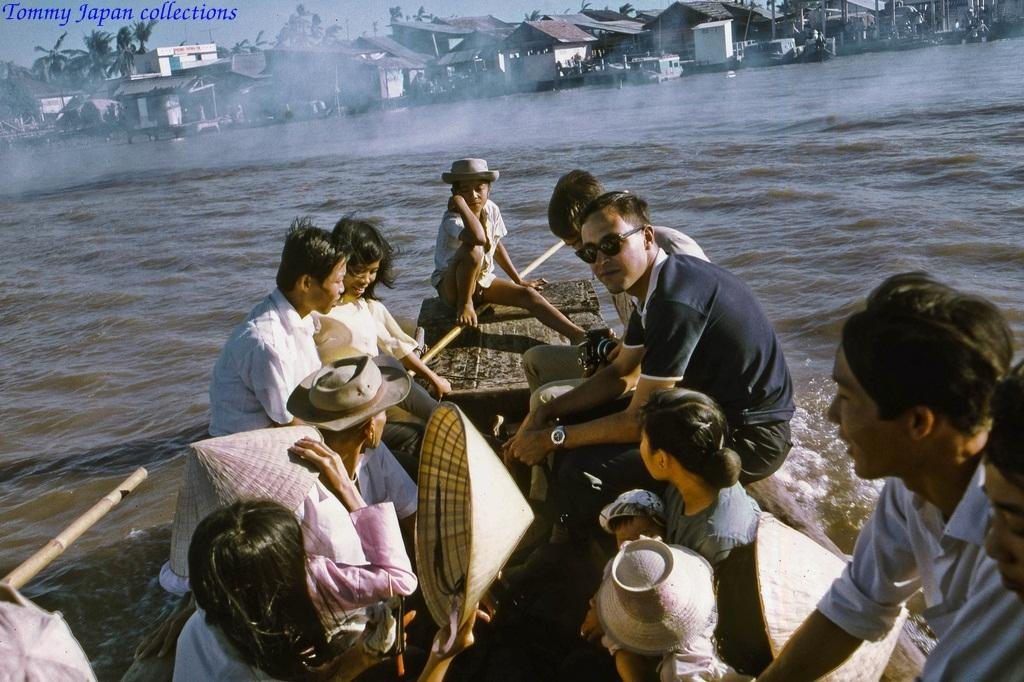What activity are the people in the image engaged in? There is a group of people boating in the water. What structures can be seen in the image? There are houses visible in the image. What type of vegetation is present in the image? There are trees visible in the image. What else can be seen in the image besides the people and structures? There is text visible in the image. What is visible in the background of the image? The sky is visible in the image. Can you describe the setting of the image? A: The image may have been taken in the ocean, as there is a group of people boating in the water. What type of pencil can be seen in the image? There is no pencil present in the image. How many cars are visible in the image? There are no cars visible in the image. 